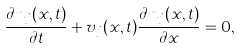Convert formula to latex. <formula><loc_0><loc_0><loc_500><loc_500>\frac { \partial n _ { j } ( x , t ) } { \partial t } + v _ { j } ( x , t ) \frac { \partial n _ { j } ( x , t ) } { \partial x } = 0 ,</formula> 